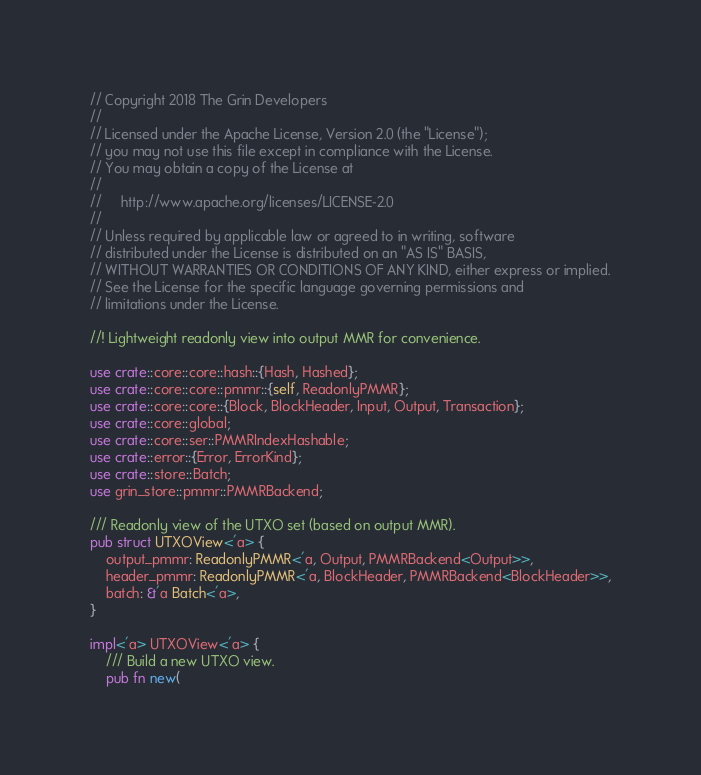<code> <loc_0><loc_0><loc_500><loc_500><_Rust_>// Copyright 2018 The Grin Developers
//
// Licensed under the Apache License, Version 2.0 (the "License");
// you may not use this file except in compliance with the License.
// You may obtain a copy of the License at
//
//     http://www.apache.org/licenses/LICENSE-2.0
//
// Unless required by applicable law or agreed to in writing, software
// distributed under the License is distributed on an "AS IS" BASIS,
// WITHOUT WARRANTIES OR CONDITIONS OF ANY KIND, either express or implied.
// See the License for the specific language governing permissions and
// limitations under the License.

//! Lightweight readonly view into output MMR for convenience.

use crate::core::core::hash::{Hash, Hashed};
use crate::core::core::pmmr::{self, ReadonlyPMMR};
use crate::core::core::{Block, BlockHeader, Input, Output, Transaction};
use crate::core::global;
use crate::core::ser::PMMRIndexHashable;
use crate::error::{Error, ErrorKind};
use crate::store::Batch;
use grin_store::pmmr::PMMRBackend;

/// Readonly view of the UTXO set (based on output MMR).
pub struct UTXOView<'a> {
	output_pmmr: ReadonlyPMMR<'a, Output, PMMRBackend<Output>>,
	header_pmmr: ReadonlyPMMR<'a, BlockHeader, PMMRBackend<BlockHeader>>,
	batch: &'a Batch<'a>,
}

impl<'a> UTXOView<'a> {
	/// Build a new UTXO view.
	pub fn new(</code> 